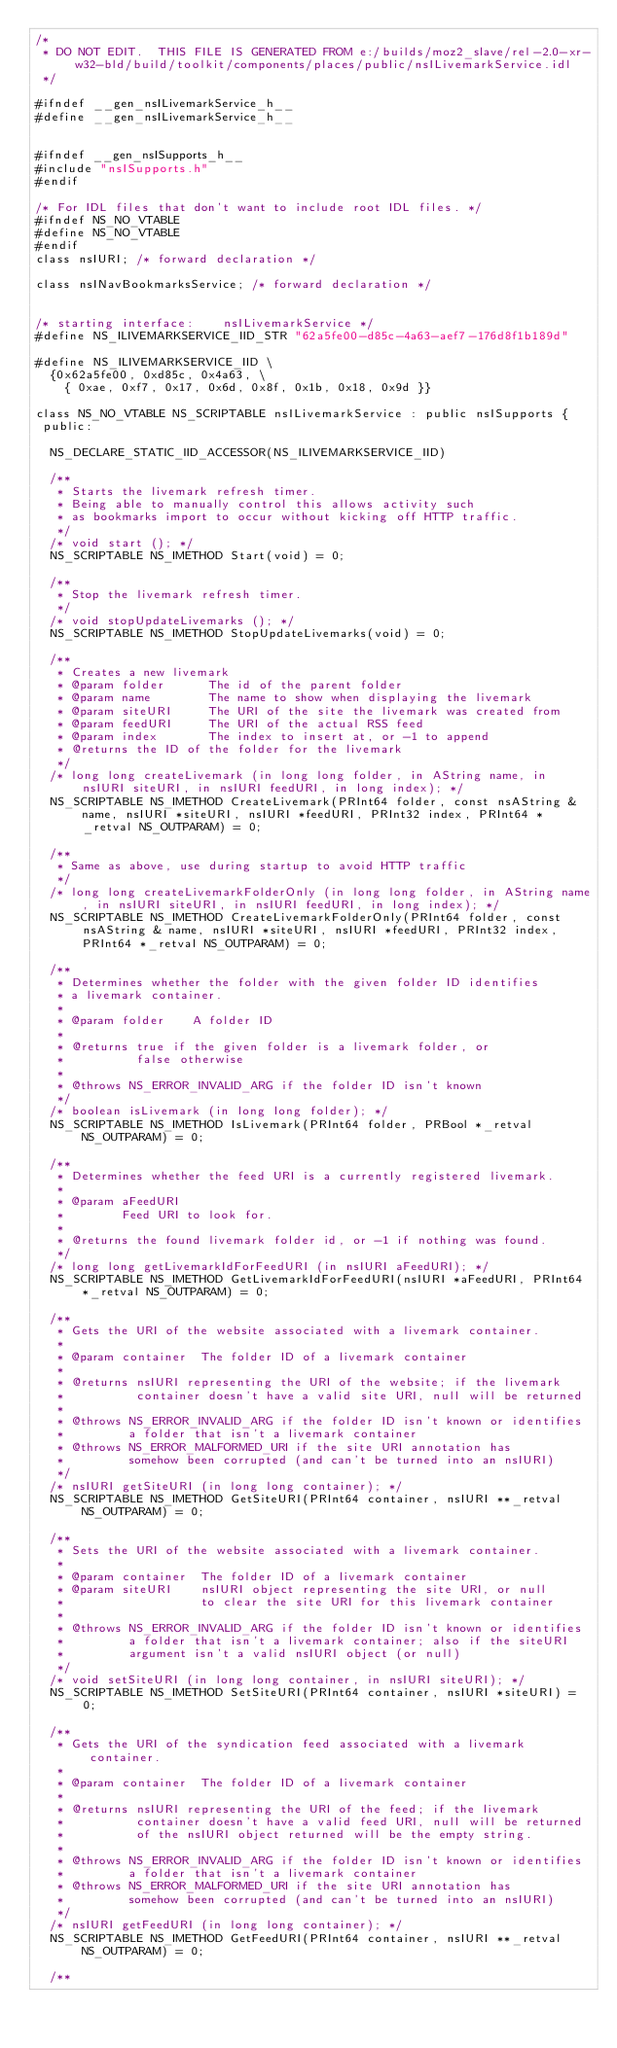<code> <loc_0><loc_0><loc_500><loc_500><_C_>/*
 * DO NOT EDIT.  THIS FILE IS GENERATED FROM e:/builds/moz2_slave/rel-2.0-xr-w32-bld/build/toolkit/components/places/public/nsILivemarkService.idl
 */

#ifndef __gen_nsILivemarkService_h__
#define __gen_nsILivemarkService_h__


#ifndef __gen_nsISupports_h__
#include "nsISupports.h"
#endif

/* For IDL files that don't want to include root IDL files. */
#ifndef NS_NO_VTABLE
#define NS_NO_VTABLE
#endif
class nsIURI; /* forward declaration */

class nsINavBookmarksService; /* forward declaration */


/* starting interface:    nsILivemarkService */
#define NS_ILIVEMARKSERVICE_IID_STR "62a5fe00-d85c-4a63-aef7-176d8f1b189d"

#define NS_ILIVEMARKSERVICE_IID \
  {0x62a5fe00, 0xd85c, 0x4a63, \
    { 0xae, 0xf7, 0x17, 0x6d, 0x8f, 0x1b, 0x18, 0x9d }}

class NS_NO_VTABLE NS_SCRIPTABLE nsILivemarkService : public nsISupports {
 public: 

  NS_DECLARE_STATIC_IID_ACCESSOR(NS_ILIVEMARKSERVICE_IID)

  /**
   * Starts the livemark refresh timer.
   * Being able to manually control this allows activity such
   * as bookmarks import to occur without kicking off HTTP traffic.
   */
  /* void start (); */
  NS_SCRIPTABLE NS_IMETHOD Start(void) = 0;

  /**
   * Stop the livemark refresh timer.
   */
  /* void stopUpdateLivemarks (); */
  NS_SCRIPTABLE NS_IMETHOD StopUpdateLivemarks(void) = 0;

  /**
   * Creates a new livemark
   * @param folder      The id of the parent folder
   * @param name        The name to show when displaying the livemark
   * @param siteURI     The URI of the site the livemark was created from
   * @param feedURI     The URI of the actual RSS feed
   * @param index       The index to insert at, or -1 to append
   * @returns the ID of the folder for the livemark
   */
  /* long long createLivemark (in long long folder, in AString name, in nsIURI siteURI, in nsIURI feedURI, in long index); */
  NS_SCRIPTABLE NS_IMETHOD CreateLivemark(PRInt64 folder, const nsAString & name, nsIURI *siteURI, nsIURI *feedURI, PRInt32 index, PRInt64 *_retval NS_OUTPARAM) = 0;

  /**
   * Same as above, use during startup to avoid HTTP traffic
   */
  /* long long createLivemarkFolderOnly (in long long folder, in AString name, in nsIURI siteURI, in nsIURI feedURI, in long index); */
  NS_SCRIPTABLE NS_IMETHOD CreateLivemarkFolderOnly(PRInt64 folder, const nsAString & name, nsIURI *siteURI, nsIURI *feedURI, PRInt32 index, PRInt64 *_retval NS_OUTPARAM) = 0;

  /**
   * Determines whether the folder with the given folder ID identifies
   * a livemark container.
   *
   * @param folder    A folder ID
   *
   * @returns true if the given folder is a livemark folder, or
   *          false otherwise
   *
   * @throws NS_ERROR_INVALID_ARG if the folder ID isn't known
   */
  /* boolean isLivemark (in long long folder); */
  NS_SCRIPTABLE NS_IMETHOD IsLivemark(PRInt64 folder, PRBool *_retval NS_OUTPARAM) = 0;

  /**
   * Determines whether the feed URI is a currently registered livemark.
   *
   * @param aFeedURI
   *        Feed URI to look for.
   *
   * @returns the found livemark folder id, or -1 if nothing was found.
   */
  /* long long getLivemarkIdForFeedURI (in nsIURI aFeedURI); */
  NS_SCRIPTABLE NS_IMETHOD GetLivemarkIdForFeedURI(nsIURI *aFeedURI, PRInt64 *_retval NS_OUTPARAM) = 0;

  /**
   * Gets the URI of the website associated with a livemark container.
   *
   * @param container  The folder ID of a livemark container
   *
   * @returns nsIURI representing the URI of the website; if the livemark
   *          container doesn't have a valid site URI, null will be returned
   *
   * @throws NS_ERROR_INVALID_ARG if the folder ID isn't known or identifies
   *         a folder that isn't a livemark container
   * @throws NS_ERROR_MALFORMED_URI if the site URI annotation has
   *         somehow been corrupted (and can't be turned into an nsIURI)
   */
  /* nsIURI getSiteURI (in long long container); */
  NS_SCRIPTABLE NS_IMETHOD GetSiteURI(PRInt64 container, nsIURI **_retval NS_OUTPARAM) = 0;

  /**
   * Sets the URI of the website associated with a livemark container.
   *
   * @param container  The folder ID of a livemark container
   * @param siteURI    nsIURI object representing the site URI, or null
   *                   to clear the site URI for this livemark container
   *
   * @throws NS_ERROR_INVALID_ARG if the folder ID isn't known or identifies
   *         a folder that isn't a livemark container; also if the siteURI
   *         argument isn't a valid nsIURI object (or null)
   */
  /* void setSiteURI (in long long container, in nsIURI siteURI); */
  NS_SCRIPTABLE NS_IMETHOD SetSiteURI(PRInt64 container, nsIURI *siteURI) = 0;

  /**
   * Gets the URI of the syndication feed associated with a livemark container.
   *
   * @param container  The folder ID of a livemark container
   *
   * @returns nsIURI representing the URI of the feed; if the livemark
   *          container doesn't have a valid feed URI, null will be returned
   *          of the nsIURI object returned will be the empty string.
   *
   * @throws NS_ERROR_INVALID_ARG if the folder ID isn't known or identifies
   *         a folder that isn't a livemark container
   * @throws NS_ERROR_MALFORMED_URI if the site URI annotation has
   *         somehow been corrupted (and can't be turned into an nsIURI)
   */
  /* nsIURI getFeedURI (in long long container); */
  NS_SCRIPTABLE NS_IMETHOD GetFeedURI(PRInt64 container, nsIURI **_retval NS_OUTPARAM) = 0;

  /**</code> 